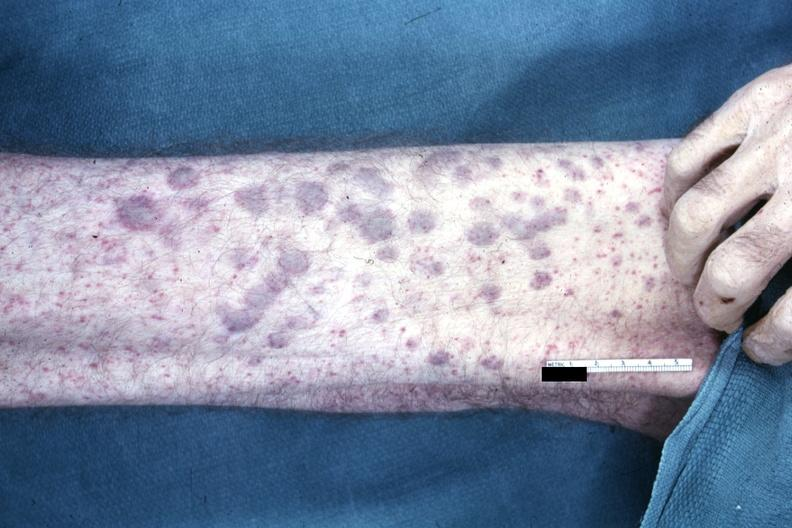s cachexia present?
Answer the question using a single word or phrase. No 